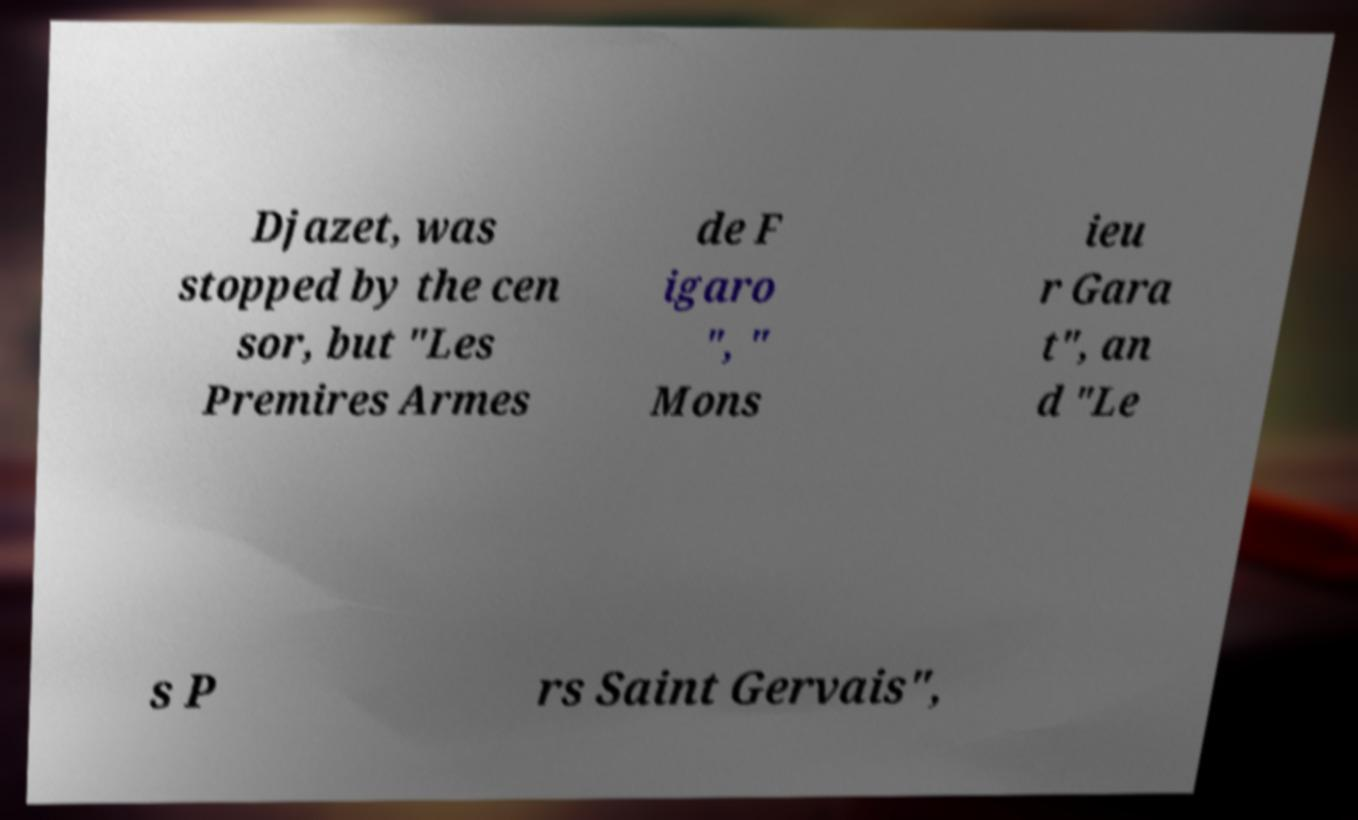Please read and relay the text visible in this image. What does it say? Djazet, was stopped by the cen sor, but "Les Premires Armes de F igaro ", " Mons ieu r Gara t", an d "Le s P rs Saint Gervais", 